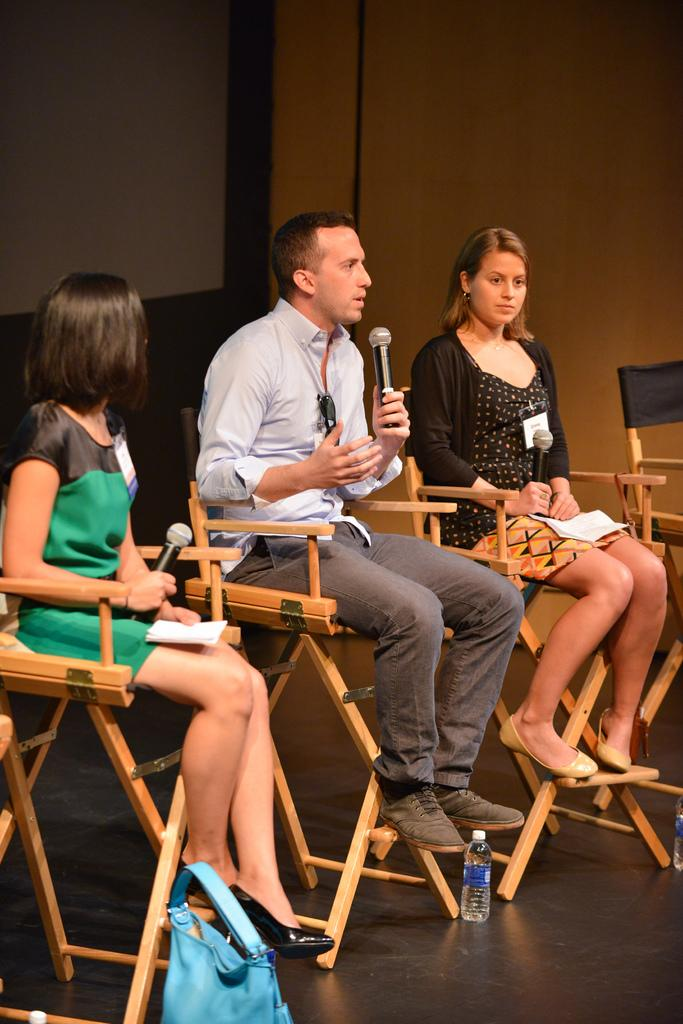What object can be seen in the image? A: There is a bottle in the image. What else is present in the image besides the bottle? There is a paper and ID cards in the image. How many people are in the image? There are three people in the image. What are the people doing in the image? The people are holding microphones and sitting on chairs. What can be seen in the background of the image? There is a wall in the background of the image. Can you tell me how many donkeys are present in the image? There are no donkeys present in the image. What type of prison can be seen in the background of the image? There is no prison present in the image; it features a wall in the background. 